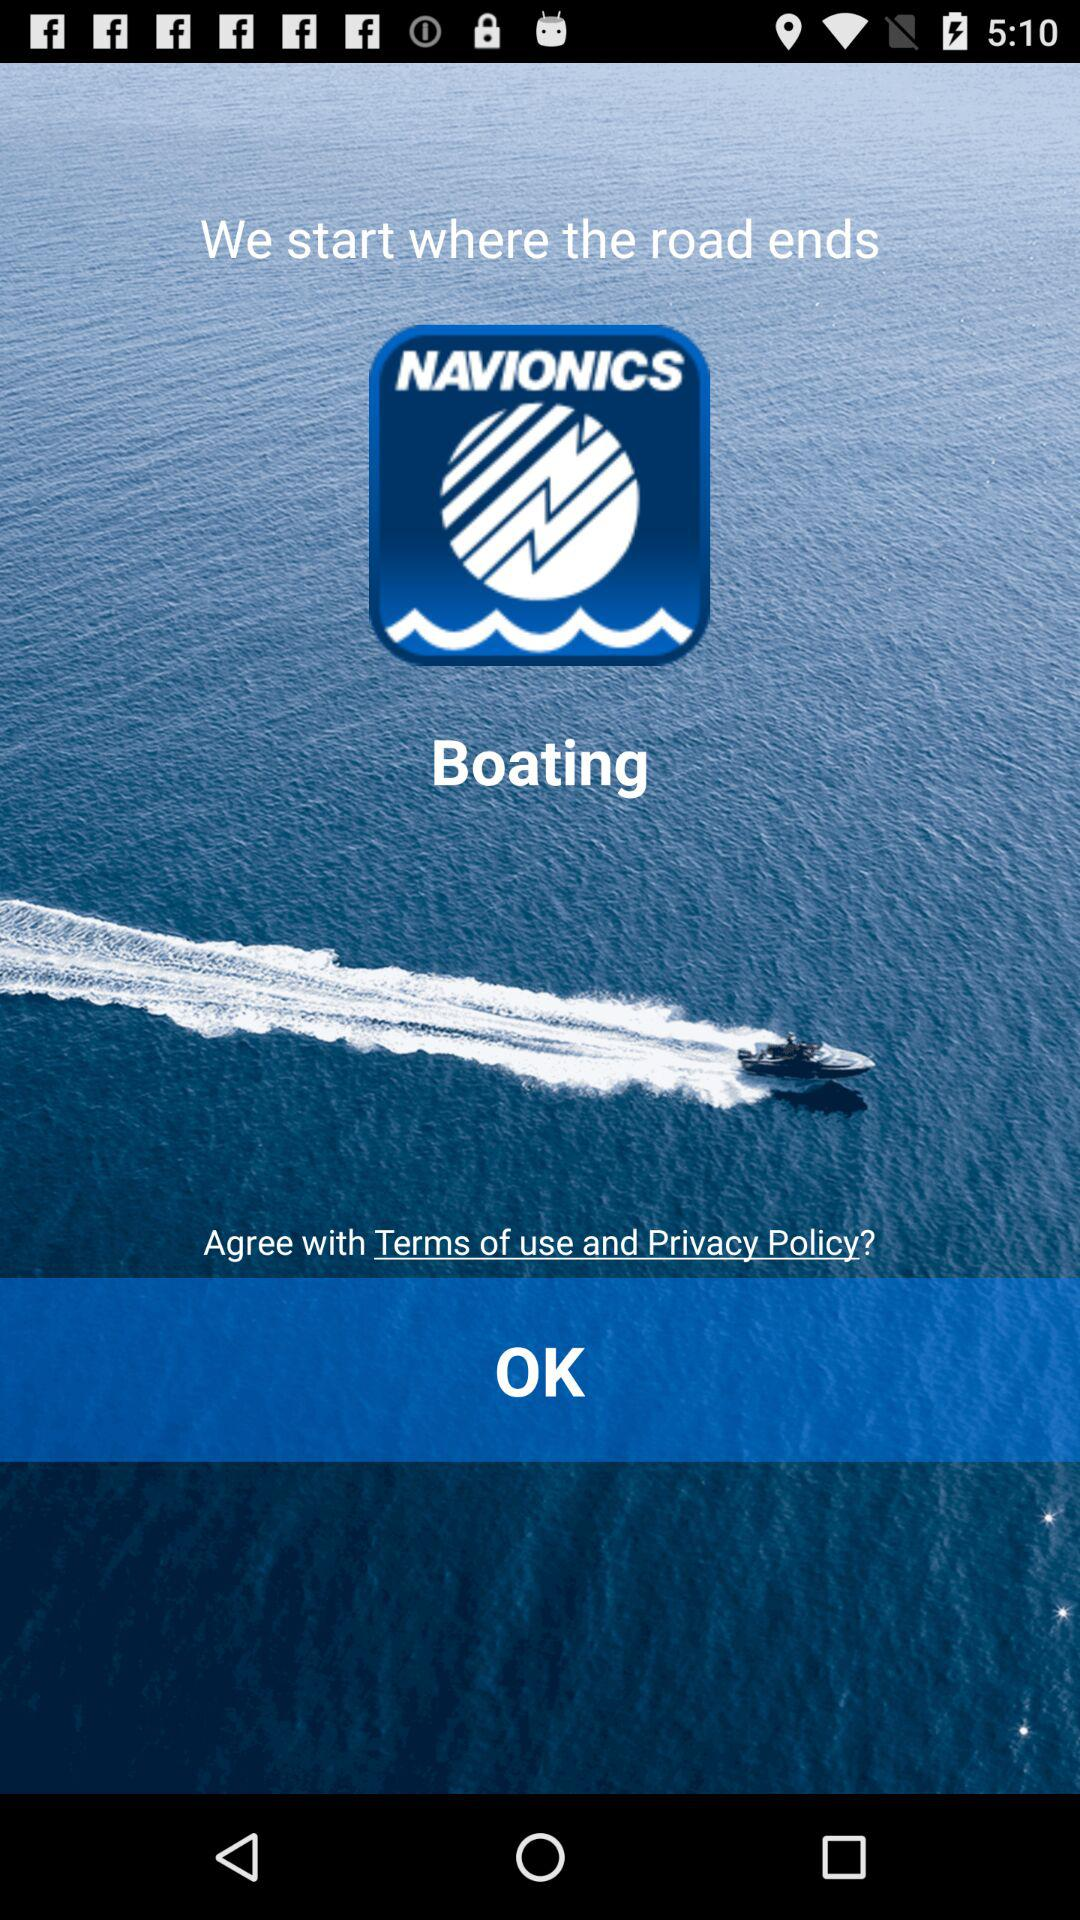What is the application name? The application name is "NAVIONICS". 